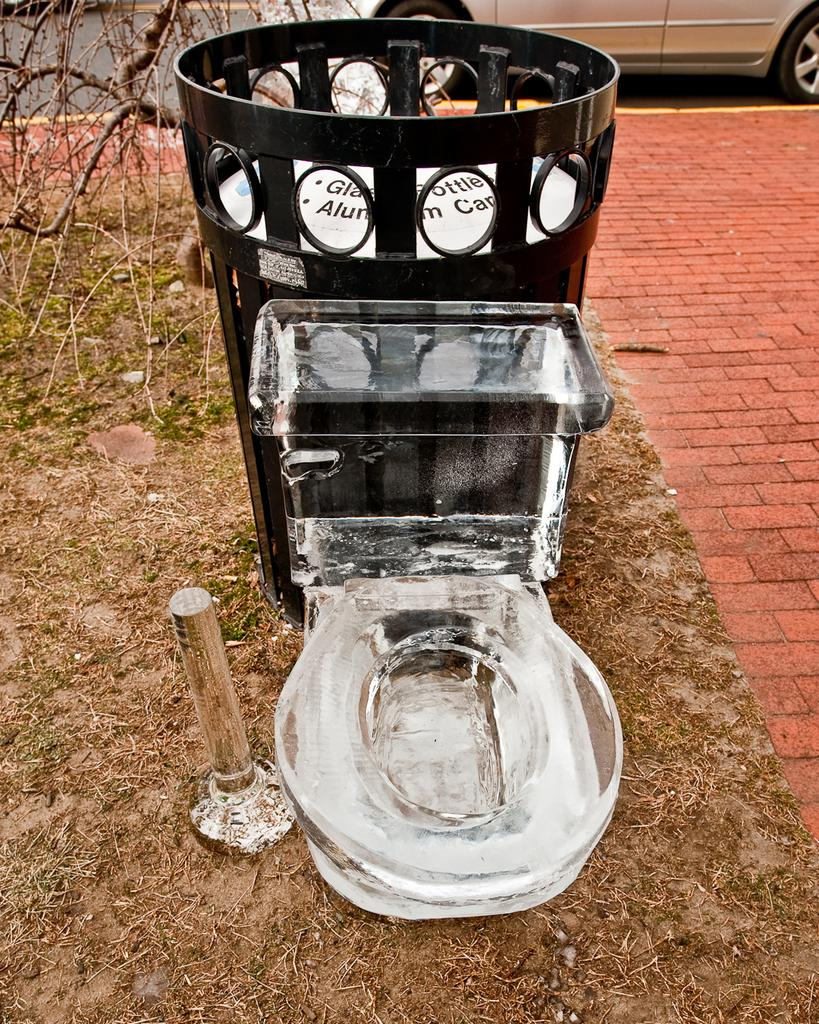<image>
Share a concise interpretation of the image provided. An usual glass toilet in front on a recycling bin, stating glass, aluminium, bottles. 